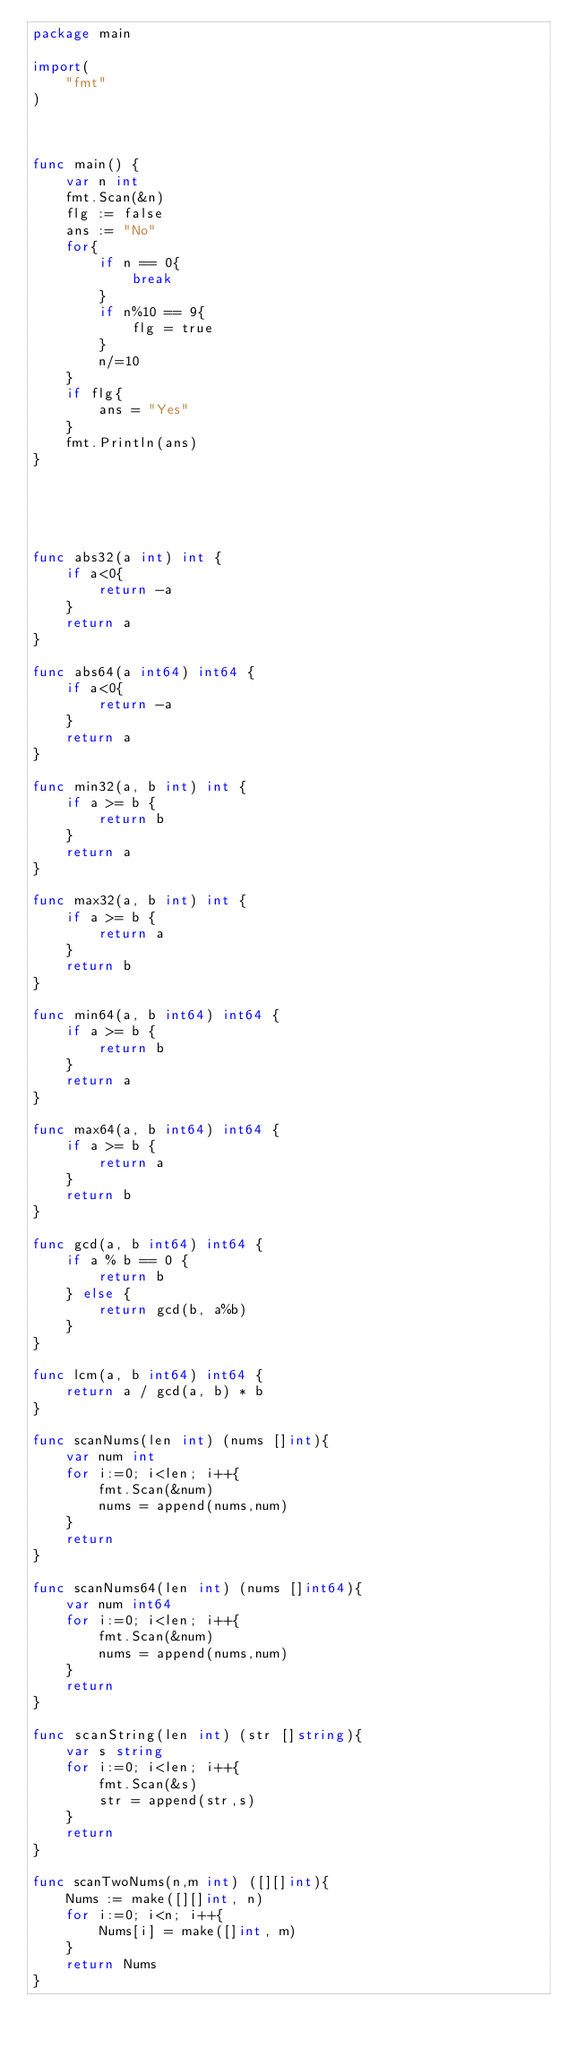<code> <loc_0><loc_0><loc_500><loc_500><_Go_>package main

import(
    "fmt"
)



func main() {
    var n int
    fmt.Scan(&n)
    flg := false
    ans := "No"
    for{
        if n == 0{
            break
        }
        if n%10 == 9{
            flg = true
        }
        n/=10
    }
    if flg{
        ans = "Yes"
    }
    fmt.Println(ans)
}





func abs32(a int) int {
    if a<0{
        return -a
    }
    return a
}

func abs64(a int64) int64 {
    if a<0{
        return -a
    }
    return a
}

func min32(a, b int) int {
    if a >= b {
        return b
    }
    return a
}

func max32(a, b int) int {
    if a >= b {
        return a
    }
    return b
}

func min64(a, b int64) int64 {
    if a >= b {
        return b
    }
    return a
}

func max64(a, b int64) int64 {
    if a >= b {
        return a
    }
    return b
}

func gcd(a, b int64) int64 {
    if a % b == 0 {
        return b
    } else {
        return gcd(b, a%b)
    }
}

func lcm(a, b int64) int64 {
    return a / gcd(a, b) * b
}

func scanNums(len int) (nums []int){
    var num int
    for i:=0; i<len; i++{
        fmt.Scan(&num)
        nums = append(nums,num)
    }
    return
}

func scanNums64(len int) (nums []int64){
    var num int64
    for i:=0; i<len; i++{
        fmt.Scan(&num)
        nums = append(nums,num)
    }
    return
}

func scanString(len int) (str []string){
    var s string
    for i:=0; i<len; i++{
        fmt.Scan(&s)
        str = append(str,s)
    }
    return
}

func scanTwoNums(n,m int) ([][]int){
    Nums := make([][]int, n)
    for i:=0; i<n; i++{
        Nums[i] = make([]int, m)
    }
    return Nums
}
</code> 